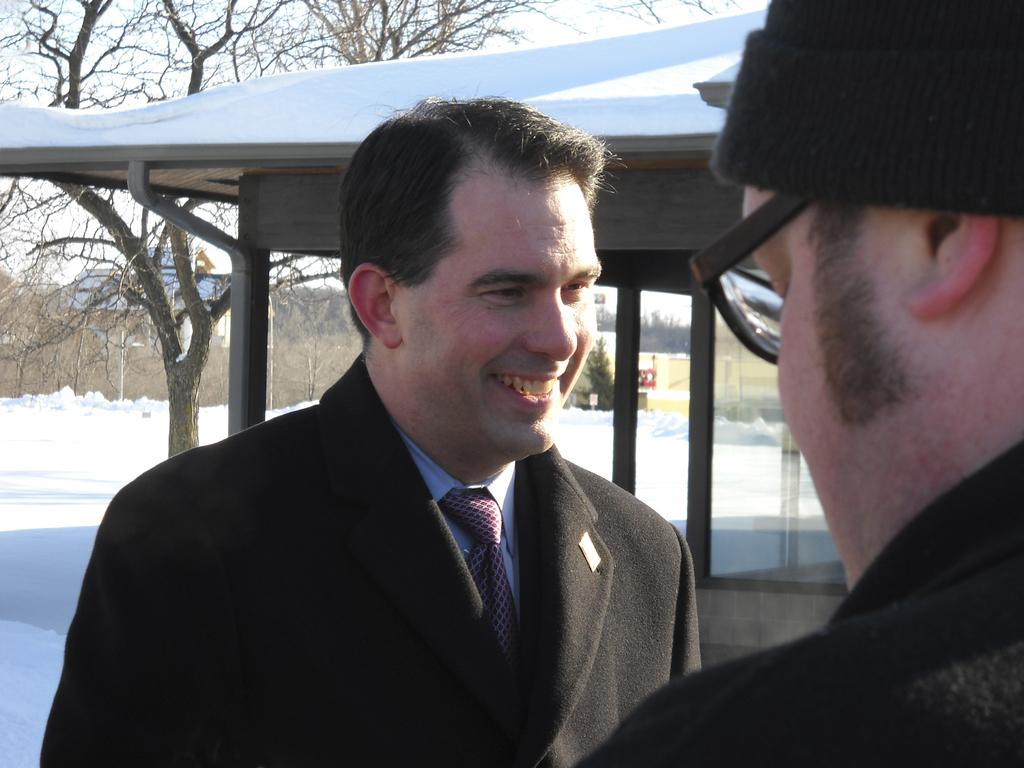How many people are in the image? There are two persons in the image. Can you describe the clothing and accessories of one of the persons? One person is wearing spectacles and a cap. How is the other person dressed in the image? The other person is wearing a coat with a tie. What can be seen in the background of the image? There is a building, a tree, and the sky visible in the background of the image. What type of letter is being delivered to the persons in the image? There is no letter present in the image, and no indication of a delivery being made. 